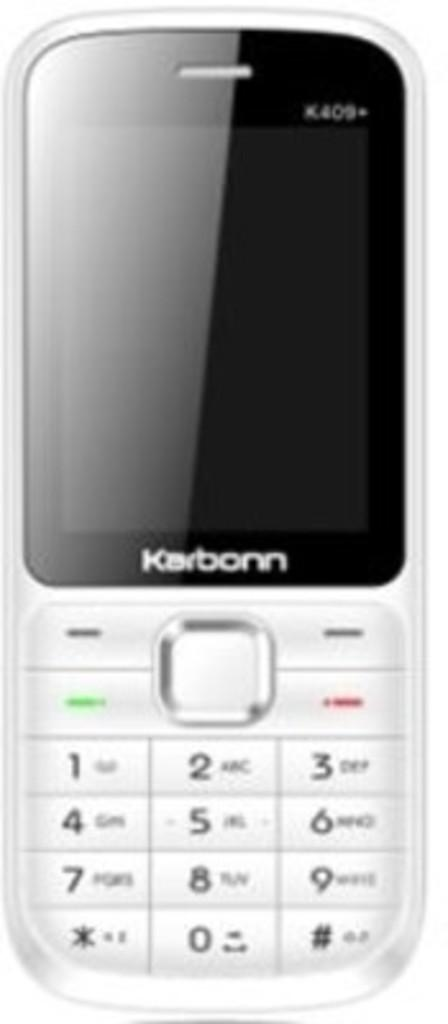<image>
Write a terse but informative summary of the picture. a close up of a Karbon cell phone in silver and black 